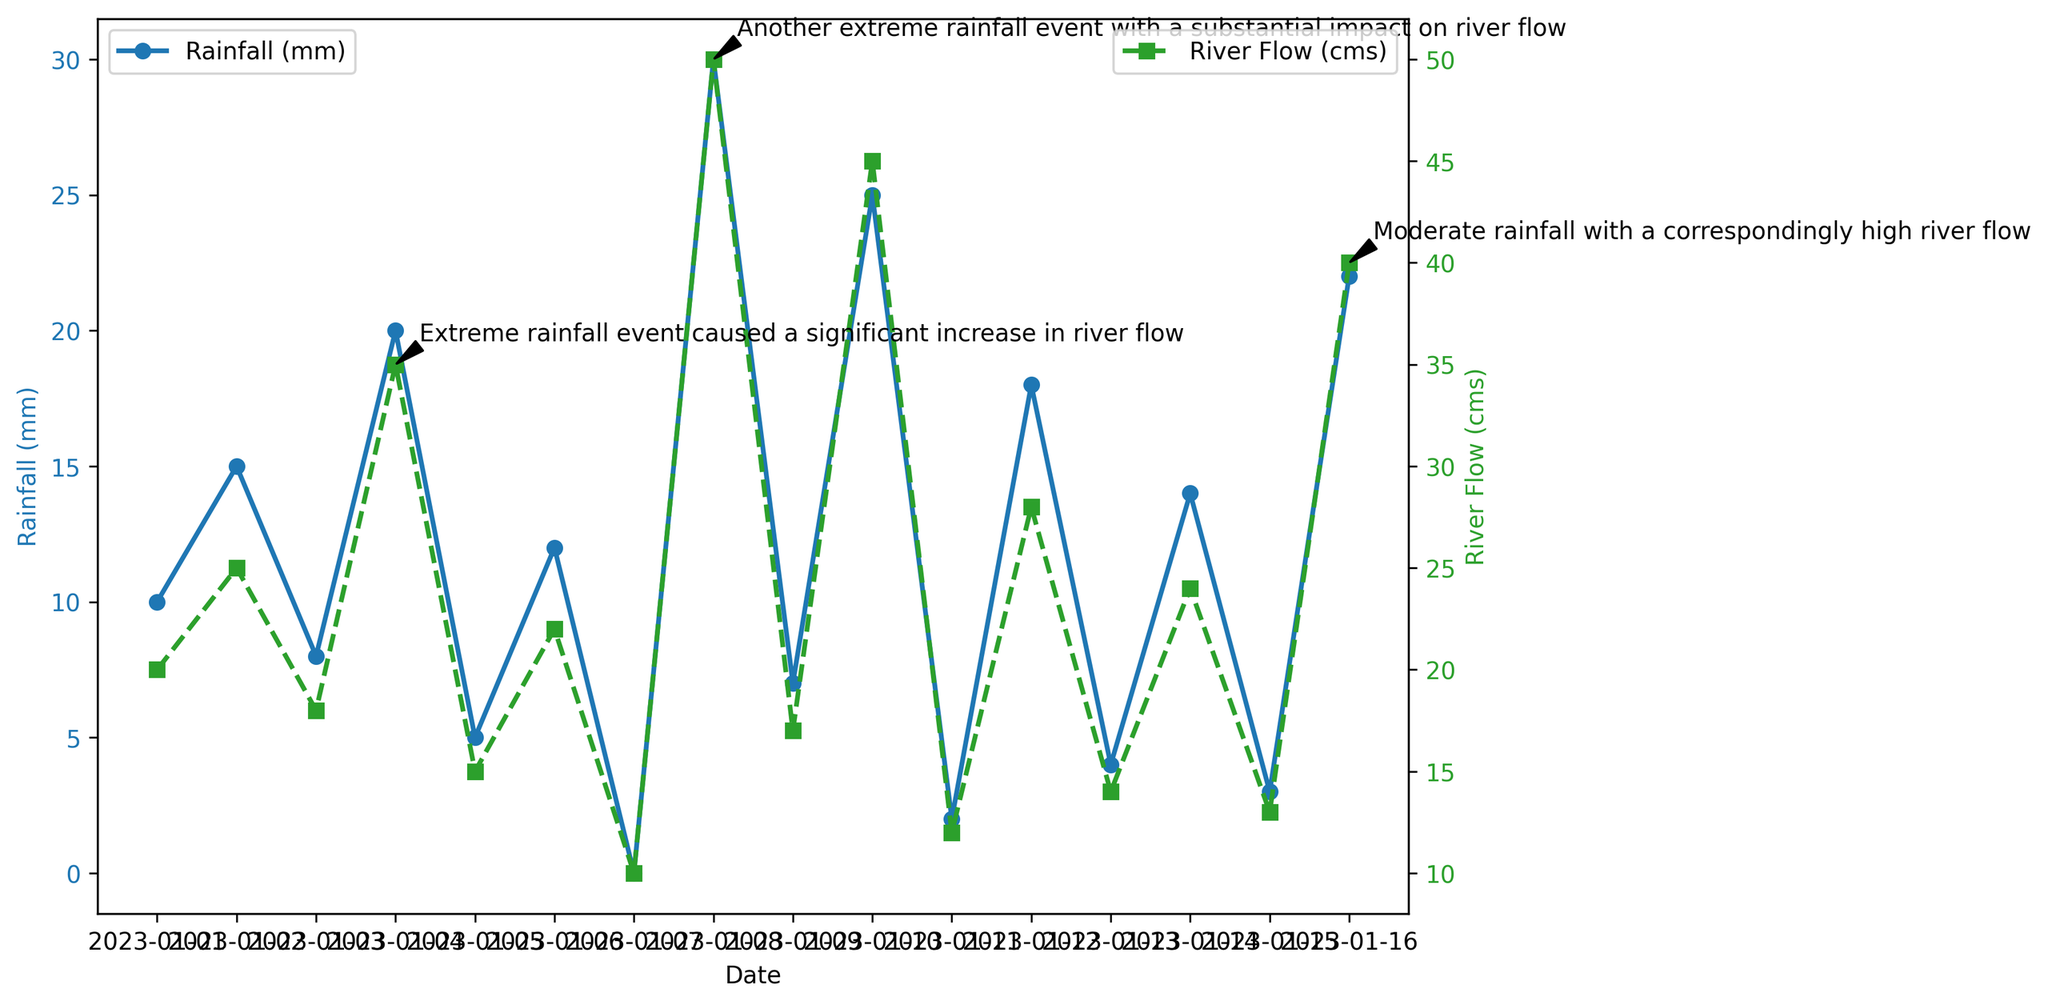Which date shows the highest rainfall? Look at the blue line representing the rainfall on the plot. The peak value for rainfall occurs on 2023-01-08.
Answer: 2023-01-08 What happened to the river flow on 2023-01-04? Refer to the annotations on the plot; on 2023-01-04, an extreme rainfall event caused a significant increase in river flow.
Answer: Significant increase Which had a higher river flow, 2023-01-06 or 2023-01-09? Compare the green markers on the dates 2023-01-06 and 2023-01-09. On 2023-01-06, river flow was 22 cms, and on 2023-01-09, it was 17 cms.
Answer: 2023-01-06 How many extreme rainfall events are annotated in the plot? Count the annotations referring to extreme rainfall events. There are two such annotations: one on 2023-01-04 and another on 2023-01-08.
Answer: 2 On which date did moderate rainfall result in a correspondingly high river flow? Look at the annotations. The annotation on 2023-01-16 mentions moderate rainfall with a correspondingly high river flow.
Answer: 2023-01-16 What is the river flow on the date with the lowest recorded rainfall? Identify the lowest blue marker for rainfall, which is 0 mm on 2023-01-07. The corresponding green marker shows a river flow of 10 cms.
Answer: 10 cms Which date shows the smallest difference between rainfall and river flow? Inspect the plot and find the smallest numerical difference between pairs of blue (rainfall) and green (river flow) markers. On 2023-01-11, rainfall was 2 mm, and river flow was 12 cms, resulting in a difference of 2 - 12 = 10. Alternatively, other dates like 2023-01-05 (5 mm vs. 15 cms) show the same difference but considering overall data, 2023-01-11 has the smallest absolute difference between values.
Answer: 2023-01-11 What is the average river flow across all dates? Sum up all river flow values (20 + 25 + 18 + 35 + 15 + 22 + 10 + 50 + 17 + 45 + 12 + 28 + 14 + 24 + 13 + 40 = 388) and divide by the number of dates (16). The average is 388 / 16.
Answer: 24.25 cms Which date shows the highest river flow and what is the value? Identify the peak of the green line representing river flow. The highest value is on 2023-01-08 with 50 cms.
Answer: 2023-01-08, 50 cms Compare the rainfall on 2023-01-02 with the rainfall on 2023-01-10. Which one is higher and by how much? The blue marker for 2023-01-02 shows 15 mm, and for 2023-01-10 it shows 25 mm. The difference is 25 - 15.
Answer: 2023-01-10, 10 mm 